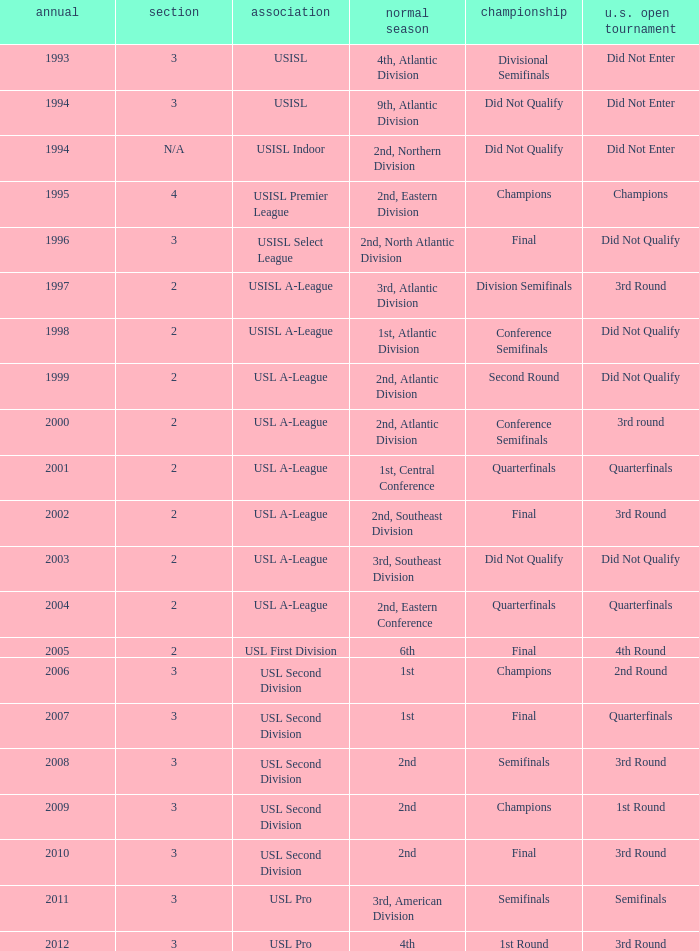What are all the playoffs for regular season is 1st, atlantic division Conference Semifinals. 